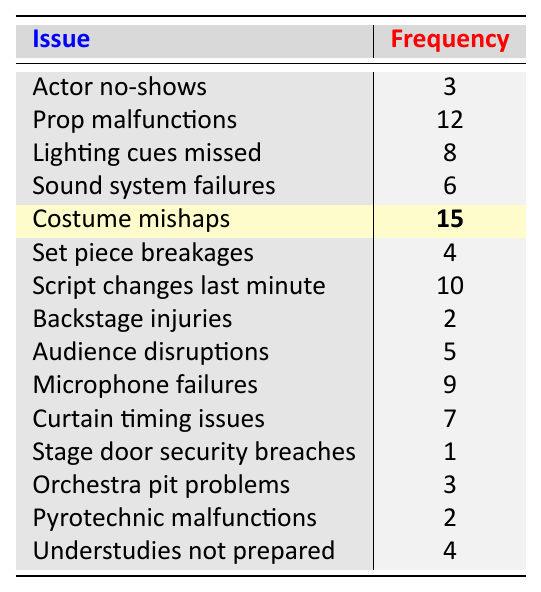What is the issue with the highest frequency? The table lists various stage management issues along with their corresponding frequencies. The highest frequency listed is for "Costume mishaps," with a frequency of 15.
Answer: Costume mishaps How many issues have a frequency of 2? By examining the frequencies, two issues—"Backstage injuries" and "Pyrotechnic malfunctions"—both show a frequency of 2.
Answer: 2 What is the sum of the frequencies for "Sound system failures" and "Lighting cues missed"? The frequency for "Sound system failures" is 6, and for "Lighting cues missed," it is 8. Adding these together: 6 + 8 = 14.
Answer: 14 Is "Stage door security breaches" the least frequent issue? The frequency for "Stage door security breaches" is 1, which is less than all other issues listed in the table. Therefore, it is the least frequent issue.
Answer: Yes What is the average frequency of issues listed in the table? There are 15 issues listed, and the total frequency is calculated by summing all frequencies: 3 + 12 + 8 + 6 + 15 + 4 + 10 + 2 + 5 + 9 + 7 + 1 + 3 + 2 + 4 =  60. The average is then 60/15 = 4.
Answer: 4 Which issue has a frequency closest to the average frequency? The average frequency calculated is 4. The issues "Set piece breakages," "Stage door security breaches," and "Pyrotechnic malfunctions" each have frequencies of 4 or lower, making them the closest to the average value.
Answer: Set piece breakages, Stage door security breaches, Pyrotechnic malfunctions What is the difference in frequency between "Prop malfunctions" and "Orchestra pit problems"? The frequency for "Prop malfunctions" is 12, while "Orchestra pit problems" has a frequency of 3. The difference is calculated as 12 - 3 = 9.
Answer: 9 How many more times frequent are "Costume mishaps" than "Backstage injuries"? "Costume mishaps" has a frequency of 15, and "Backstage injuries" has a frequency of 2. The ratio is 15 divided by 2, which is 7.5.
Answer: 7.5 